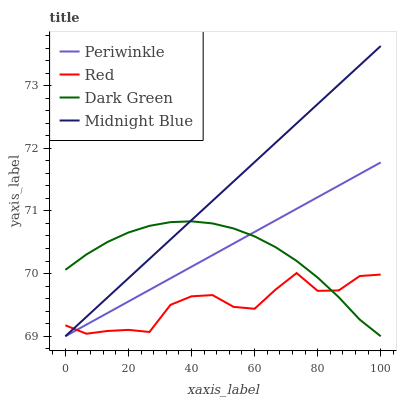Does Red have the minimum area under the curve?
Answer yes or no. Yes. Does Midnight Blue have the maximum area under the curve?
Answer yes or no. Yes. Does Midnight Blue have the minimum area under the curve?
Answer yes or no. No. Does Red have the maximum area under the curve?
Answer yes or no. No. Is Midnight Blue the smoothest?
Answer yes or no. Yes. Is Red the roughest?
Answer yes or no. Yes. Is Red the smoothest?
Answer yes or no. No. Is Midnight Blue the roughest?
Answer yes or no. No. Does Periwinkle have the lowest value?
Answer yes or no. Yes. Does Red have the lowest value?
Answer yes or no. No. Does Midnight Blue have the highest value?
Answer yes or no. Yes. Does Red have the highest value?
Answer yes or no. No. Does Red intersect Dark Green?
Answer yes or no. Yes. Is Red less than Dark Green?
Answer yes or no. No. Is Red greater than Dark Green?
Answer yes or no. No. 